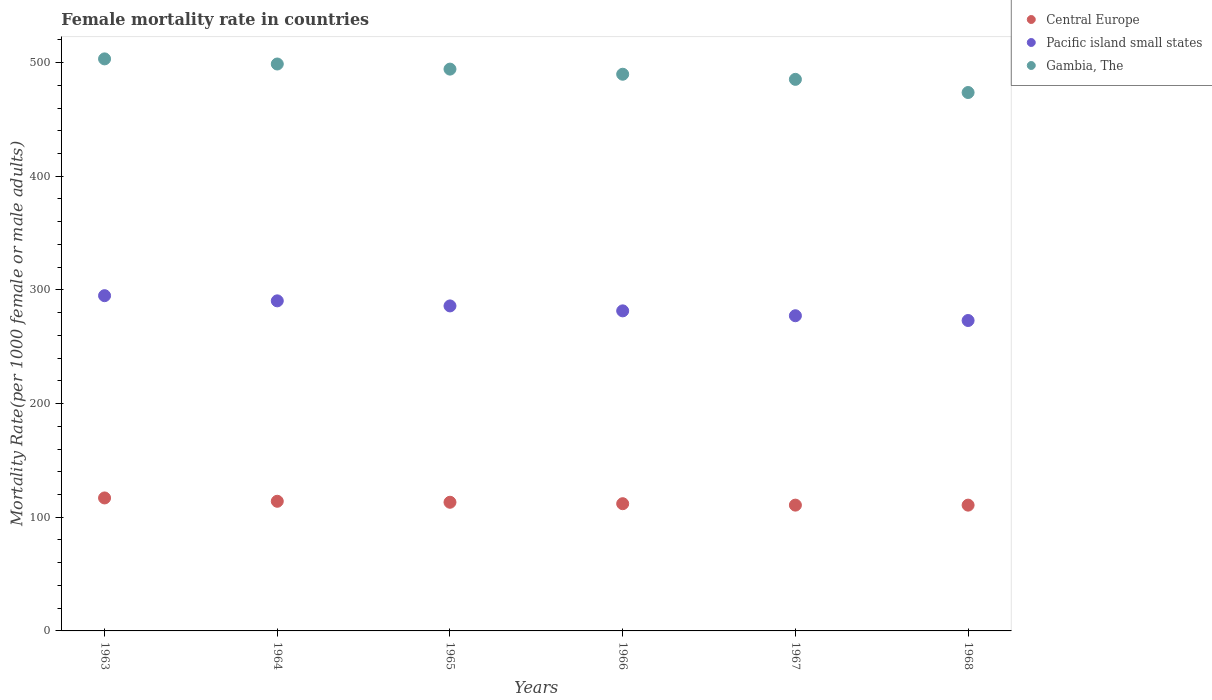How many different coloured dotlines are there?
Offer a terse response. 3. What is the female mortality rate in Gambia, The in 1965?
Provide a short and direct response. 494.21. Across all years, what is the maximum female mortality rate in Pacific island small states?
Ensure brevity in your answer.  294.91. Across all years, what is the minimum female mortality rate in Gambia, The?
Your response must be concise. 473.63. In which year was the female mortality rate in Pacific island small states maximum?
Give a very brief answer. 1963. In which year was the female mortality rate in Central Europe minimum?
Make the answer very short. 1968. What is the total female mortality rate in Pacific island small states in the graph?
Provide a short and direct response. 1703.05. What is the difference between the female mortality rate in Gambia, The in 1966 and that in 1968?
Give a very brief answer. 16.08. What is the difference between the female mortality rate in Central Europe in 1966 and the female mortality rate in Gambia, The in 1967?
Your answer should be compact. -373.3. What is the average female mortality rate in Pacific island small states per year?
Keep it short and to the point. 283.84. In the year 1967, what is the difference between the female mortality rate in Gambia, The and female mortality rate in Central Europe?
Your answer should be very brief. 374.55. In how many years, is the female mortality rate in Pacific island small states greater than 240?
Offer a very short reply. 6. What is the ratio of the female mortality rate in Pacific island small states in 1964 to that in 1965?
Offer a terse response. 1.02. Is the female mortality rate in Pacific island small states in 1966 less than that in 1967?
Make the answer very short. No. Is the difference between the female mortality rate in Gambia, The in 1963 and 1965 greater than the difference between the female mortality rate in Central Europe in 1963 and 1965?
Provide a succinct answer. Yes. What is the difference between the highest and the second highest female mortality rate in Central Europe?
Your response must be concise. 2.92. What is the difference between the highest and the lowest female mortality rate in Central Europe?
Make the answer very short. 6.32. In how many years, is the female mortality rate in Gambia, The greater than the average female mortality rate in Gambia, The taken over all years?
Provide a short and direct response. 3. Does the female mortality rate in Gambia, The monotonically increase over the years?
Make the answer very short. No. Is the female mortality rate in Central Europe strictly less than the female mortality rate in Pacific island small states over the years?
Your answer should be very brief. Yes. How many dotlines are there?
Your answer should be very brief. 3. Does the graph contain grids?
Provide a succinct answer. No. Where does the legend appear in the graph?
Make the answer very short. Top right. How many legend labels are there?
Offer a terse response. 3. What is the title of the graph?
Offer a terse response. Female mortality rate in countries. Does "Marshall Islands" appear as one of the legend labels in the graph?
Give a very brief answer. No. What is the label or title of the Y-axis?
Keep it short and to the point. Mortality Rate(per 1000 female or male adults). What is the Mortality Rate(per 1000 female or male adults) in Central Europe in 1963?
Your answer should be very brief. 116.97. What is the Mortality Rate(per 1000 female or male adults) in Pacific island small states in 1963?
Provide a succinct answer. 294.91. What is the Mortality Rate(per 1000 female or male adults) of Gambia, The in 1963?
Give a very brief answer. 503.21. What is the Mortality Rate(per 1000 female or male adults) in Central Europe in 1964?
Your response must be concise. 114.05. What is the Mortality Rate(per 1000 female or male adults) of Pacific island small states in 1964?
Offer a terse response. 290.36. What is the Mortality Rate(per 1000 female or male adults) in Gambia, The in 1964?
Give a very brief answer. 498.71. What is the Mortality Rate(per 1000 female or male adults) of Central Europe in 1965?
Provide a short and direct response. 113.18. What is the Mortality Rate(per 1000 female or male adults) in Pacific island small states in 1965?
Your answer should be very brief. 285.9. What is the Mortality Rate(per 1000 female or male adults) in Gambia, The in 1965?
Make the answer very short. 494.21. What is the Mortality Rate(per 1000 female or male adults) of Central Europe in 1966?
Provide a succinct answer. 111.91. What is the Mortality Rate(per 1000 female or male adults) in Pacific island small states in 1966?
Offer a terse response. 281.55. What is the Mortality Rate(per 1000 female or male adults) of Gambia, The in 1966?
Keep it short and to the point. 489.71. What is the Mortality Rate(per 1000 female or male adults) in Central Europe in 1967?
Your answer should be compact. 110.66. What is the Mortality Rate(per 1000 female or male adults) in Pacific island small states in 1967?
Offer a very short reply. 277.26. What is the Mortality Rate(per 1000 female or male adults) in Gambia, The in 1967?
Your response must be concise. 485.21. What is the Mortality Rate(per 1000 female or male adults) of Central Europe in 1968?
Your response must be concise. 110.65. What is the Mortality Rate(per 1000 female or male adults) in Pacific island small states in 1968?
Your answer should be compact. 273.07. What is the Mortality Rate(per 1000 female or male adults) in Gambia, The in 1968?
Offer a terse response. 473.63. Across all years, what is the maximum Mortality Rate(per 1000 female or male adults) of Central Europe?
Provide a succinct answer. 116.97. Across all years, what is the maximum Mortality Rate(per 1000 female or male adults) in Pacific island small states?
Make the answer very short. 294.91. Across all years, what is the maximum Mortality Rate(per 1000 female or male adults) of Gambia, The?
Your response must be concise. 503.21. Across all years, what is the minimum Mortality Rate(per 1000 female or male adults) of Central Europe?
Make the answer very short. 110.65. Across all years, what is the minimum Mortality Rate(per 1000 female or male adults) of Pacific island small states?
Provide a succinct answer. 273.07. Across all years, what is the minimum Mortality Rate(per 1000 female or male adults) in Gambia, The?
Your response must be concise. 473.63. What is the total Mortality Rate(per 1000 female or male adults) of Central Europe in the graph?
Your answer should be compact. 677.43. What is the total Mortality Rate(per 1000 female or male adults) of Pacific island small states in the graph?
Offer a very short reply. 1703.05. What is the total Mortality Rate(per 1000 female or male adults) of Gambia, The in the graph?
Your answer should be very brief. 2944.68. What is the difference between the Mortality Rate(per 1000 female or male adults) in Central Europe in 1963 and that in 1964?
Provide a succinct answer. 2.92. What is the difference between the Mortality Rate(per 1000 female or male adults) in Pacific island small states in 1963 and that in 1964?
Make the answer very short. 4.55. What is the difference between the Mortality Rate(per 1000 female or male adults) in Gambia, The in 1963 and that in 1964?
Your answer should be compact. 4.5. What is the difference between the Mortality Rate(per 1000 female or male adults) of Central Europe in 1963 and that in 1965?
Offer a terse response. 3.79. What is the difference between the Mortality Rate(per 1000 female or male adults) in Pacific island small states in 1963 and that in 1965?
Make the answer very short. 9.01. What is the difference between the Mortality Rate(per 1000 female or male adults) of Gambia, The in 1963 and that in 1965?
Provide a short and direct response. 9. What is the difference between the Mortality Rate(per 1000 female or male adults) in Central Europe in 1963 and that in 1966?
Your answer should be very brief. 5.06. What is the difference between the Mortality Rate(per 1000 female or male adults) of Pacific island small states in 1963 and that in 1966?
Make the answer very short. 13.37. What is the difference between the Mortality Rate(per 1000 female or male adults) in Gambia, The in 1963 and that in 1966?
Provide a succinct answer. 13.5. What is the difference between the Mortality Rate(per 1000 female or male adults) in Central Europe in 1963 and that in 1967?
Offer a very short reply. 6.31. What is the difference between the Mortality Rate(per 1000 female or male adults) of Pacific island small states in 1963 and that in 1967?
Ensure brevity in your answer.  17.65. What is the difference between the Mortality Rate(per 1000 female or male adults) of Gambia, The in 1963 and that in 1967?
Offer a terse response. 18. What is the difference between the Mortality Rate(per 1000 female or male adults) in Central Europe in 1963 and that in 1968?
Ensure brevity in your answer.  6.32. What is the difference between the Mortality Rate(per 1000 female or male adults) of Pacific island small states in 1963 and that in 1968?
Offer a very short reply. 21.85. What is the difference between the Mortality Rate(per 1000 female or male adults) in Gambia, The in 1963 and that in 1968?
Provide a short and direct response. 29.58. What is the difference between the Mortality Rate(per 1000 female or male adults) of Central Europe in 1964 and that in 1965?
Offer a very short reply. 0.87. What is the difference between the Mortality Rate(per 1000 female or male adults) of Pacific island small states in 1964 and that in 1965?
Provide a short and direct response. 4.46. What is the difference between the Mortality Rate(per 1000 female or male adults) in Gambia, The in 1964 and that in 1965?
Keep it short and to the point. 4.5. What is the difference between the Mortality Rate(per 1000 female or male adults) in Central Europe in 1964 and that in 1966?
Give a very brief answer. 2.14. What is the difference between the Mortality Rate(per 1000 female or male adults) in Pacific island small states in 1964 and that in 1966?
Keep it short and to the point. 8.81. What is the difference between the Mortality Rate(per 1000 female or male adults) in Gambia, The in 1964 and that in 1966?
Ensure brevity in your answer.  9. What is the difference between the Mortality Rate(per 1000 female or male adults) of Central Europe in 1964 and that in 1967?
Give a very brief answer. 3.39. What is the difference between the Mortality Rate(per 1000 female or male adults) of Pacific island small states in 1964 and that in 1967?
Provide a short and direct response. 13.1. What is the difference between the Mortality Rate(per 1000 female or male adults) in Gambia, The in 1964 and that in 1967?
Offer a terse response. 13.5. What is the difference between the Mortality Rate(per 1000 female or male adults) of Central Europe in 1964 and that in 1968?
Provide a short and direct response. 3.4. What is the difference between the Mortality Rate(per 1000 female or male adults) in Pacific island small states in 1964 and that in 1968?
Keep it short and to the point. 17.29. What is the difference between the Mortality Rate(per 1000 female or male adults) of Gambia, The in 1964 and that in 1968?
Give a very brief answer. 25.08. What is the difference between the Mortality Rate(per 1000 female or male adults) in Central Europe in 1965 and that in 1966?
Ensure brevity in your answer.  1.27. What is the difference between the Mortality Rate(per 1000 female or male adults) in Pacific island small states in 1965 and that in 1966?
Your answer should be very brief. 4.35. What is the difference between the Mortality Rate(per 1000 female or male adults) in Gambia, The in 1965 and that in 1966?
Your response must be concise. 4.5. What is the difference between the Mortality Rate(per 1000 female or male adults) of Central Europe in 1965 and that in 1967?
Provide a succinct answer. 2.52. What is the difference between the Mortality Rate(per 1000 female or male adults) of Pacific island small states in 1965 and that in 1967?
Offer a terse response. 8.64. What is the difference between the Mortality Rate(per 1000 female or male adults) in Gambia, The in 1965 and that in 1967?
Ensure brevity in your answer.  9. What is the difference between the Mortality Rate(per 1000 female or male adults) in Central Europe in 1965 and that in 1968?
Provide a succinct answer. 2.53. What is the difference between the Mortality Rate(per 1000 female or male adults) of Pacific island small states in 1965 and that in 1968?
Make the answer very short. 12.83. What is the difference between the Mortality Rate(per 1000 female or male adults) in Gambia, The in 1965 and that in 1968?
Your answer should be very brief. 20.58. What is the difference between the Mortality Rate(per 1000 female or male adults) in Central Europe in 1966 and that in 1967?
Offer a very short reply. 1.25. What is the difference between the Mortality Rate(per 1000 female or male adults) in Pacific island small states in 1966 and that in 1967?
Offer a very short reply. 4.29. What is the difference between the Mortality Rate(per 1000 female or male adults) in Gambia, The in 1966 and that in 1967?
Keep it short and to the point. 4.5. What is the difference between the Mortality Rate(per 1000 female or male adults) in Central Europe in 1966 and that in 1968?
Give a very brief answer. 1.26. What is the difference between the Mortality Rate(per 1000 female or male adults) in Pacific island small states in 1966 and that in 1968?
Ensure brevity in your answer.  8.48. What is the difference between the Mortality Rate(per 1000 female or male adults) of Gambia, The in 1966 and that in 1968?
Provide a succinct answer. 16.08. What is the difference between the Mortality Rate(per 1000 female or male adults) in Central Europe in 1967 and that in 1968?
Your answer should be compact. 0.01. What is the difference between the Mortality Rate(per 1000 female or male adults) of Pacific island small states in 1967 and that in 1968?
Offer a very short reply. 4.2. What is the difference between the Mortality Rate(per 1000 female or male adults) in Gambia, The in 1967 and that in 1968?
Offer a terse response. 11.58. What is the difference between the Mortality Rate(per 1000 female or male adults) of Central Europe in 1963 and the Mortality Rate(per 1000 female or male adults) of Pacific island small states in 1964?
Your answer should be very brief. -173.39. What is the difference between the Mortality Rate(per 1000 female or male adults) of Central Europe in 1963 and the Mortality Rate(per 1000 female or male adults) of Gambia, The in 1964?
Provide a short and direct response. -381.74. What is the difference between the Mortality Rate(per 1000 female or male adults) in Pacific island small states in 1963 and the Mortality Rate(per 1000 female or male adults) in Gambia, The in 1964?
Offer a very short reply. -203.8. What is the difference between the Mortality Rate(per 1000 female or male adults) of Central Europe in 1963 and the Mortality Rate(per 1000 female or male adults) of Pacific island small states in 1965?
Offer a very short reply. -168.93. What is the difference between the Mortality Rate(per 1000 female or male adults) in Central Europe in 1963 and the Mortality Rate(per 1000 female or male adults) in Gambia, The in 1965?
Offer a very short reply. -377.24. What is the difference between the Mortality Rate(per 1000 female or male adults) of Pacific island small states in 1963 and the Mortality Rate(per 1000 female or male adults) of Gambia, The in 1965?
Give a very brief answer. -199.3. What is the difference between the Mortality Rate(per 1000 female or male adults) in Central Europe in 1963 and the Mortality Rate(per 1000 female or male adults) in Pacific island small states in 1966?
Your response must be concise. -164.57. What is the difference between the Mortality Rate(per 1000 female or male adults) of Central Europe in 1963 and the Mortality Rate(per 1000 female or male adults) of Gambia, The in 1966?
Make the answer very short. -372.73. What is the difference between the Mortality Rate(per 1000 female or male adults) in Pacific island small states in 1963 and the Mortality Rate(per 1000 female or male adults) in Gambia, The in 1966?
Provide a short and direct response. -194.79. What is the difference between the Mortality Rate(per 1000 female or male adults) of Central Europe in 1963 and the Mortality Rate(per 1000 female or male adults) of Pacific island small states in 1967?
Offer a very short reply. -160.29. What is the difference between the Mortality Rate(per 1000 female or male adults) in Central Europe in 1963 and the Mortality Rate(per 1000 female or male adults) in Gambia, The in 1967?
Keep it short and to the point. -368.23. What is the difference between the Mortality Rate(per 1000 female or male adults) of Pacific island small states in 1963 and the Mortality Rate(per 1000 female or male adults) of Gambia, The in 1967?
Ensure brevity in your answer.  -190.29. What is the difference between the Mortality Rate(per 1000 female or male adults) of Central Europe in 1963 and the Mortality Rate(per 1000 female or male adults) of Pacific island small states in 1968?
Give a very brief answer. -156.09. What is the difference between the Mortality Rate(per 1000 female or male adults) of Central Europe in 1963 and the Mortality Rate(per 1000 female or male adults) of Gambia, The in 1968?
Your response must be concise. -356.66. What is the difference between the Mortality Rate(per 1000 female or male adults) in Pacific island small states in 1963 and the Mortality Rate(per 1000 female or male adults) in Gambia, The in 1968?
Your answer should be very brief. -178.72. What is the difference between the Mortality Rate(per 1000 female or male adults) in Central Europe in 1964 and the Mortality Rate(per 1000 female or male adults) in Pacific island small states in 1965?
Keep it short and to the point. -171.85. What is the difference between the Mortality Rate(per 1000 female or male adults) of Central Europe in 1964 and the Mortality Rate(per 1000 female or male adults) of Gambia, The in 1965?
Keep it short and to the point. -380.16. What is the difference between the Mortality Rate(per 1000 female or male adults) in Pacific island small states in 1964 and the Mortality Rate(per 1000 female or male adults) in Gambia, The in 1965?
Offer a very short reply. -203.85. What is the difference between the Mortality Rate(per 1000 female or male adults) of Central Europe in 1964 and the Mortality Rate(per 1000 female or male adults) of Pacific island small states in 1966?
Provide a succinct answer. -167.5. What is the difference between the Mortality Rate(per 1000 female or male adults) of Central Europe in 1964 and the Mortality Rate(per 1000 female or male adults) of Gambia, The in 1966?
Provide a short and direct response. -375.66. What is the difference between the Mortality Rate(per 1000 female or male adults) of Pacific island small states in 1964 and the Mortality Rate(per 1000 female or male adults) of Gambia, The in 1966?
Your answer should be very brief. -199.35. What is the difference between the Mortality Rate(per 1000 female or male adults) in Central Europe in 1964 and the Mortality Rate(per 1000 female or male adults) in Pacific island small states in 1967?
Provide a succinct answer. -163.21. What is the difference between the Mortality Rate(per 1000 female or male adults) in Central Europe in 1964 and the Mortality Rate(per 1000 female or male adults) in Gambia, The in 1967?
Offer a very short reply. -371.16. What is the difference between the Mortality Rate(per 1000 female or male adults) of Pacific island small states in 1964 and the Mortality Rate(per 1000 female or male adults) of Gambia, The in 1967?
Offer a very short reply. -194.85. What is the difference between the Mortality Rate(per 1000 female or male adults) in Central Europe in 1964 and the Mortality Rate(per 1000 female or male adults) in Pacific island small states in 1968?
Your response must be concise. -159.01. What is the difference between the Mortality Rate(per 1000 female or male adults) in Central Europe in 1964 and the Mortality Rate(per 1000 female or male adults) in Gambia, The in 1968?
Provide a short and direct response. -359.58. What is the difference between the Mortality Rate(per 1000 female or male adults) of Pacific island small states in 1964 and the Mortality Rate(per 1000 female or male adults) of Gambia, The in 1968?
Keep it short and to the point. -183.27. What is the difference between the Mortality Rate(per 1000 female or male adults) of Central Europe in 1965 and the Mortality Rate(per 1000 female or male adults) of Pacific island small states in 1966?
Make the answer very short. -168.37. What is the difference between the Mortality Rate(per 1000 female or male adults) in Central Europe in 1965 and the Mortality Rate(per 1000 female or male adults) in Gambia, The in 1966?
Your answer should be compact. -376.53. What is the difference between the Mortality Rate(per 1000 female or male adults) of Pacific island small states in 1965 and the Mortality Rate(per 1000 female or male adults) of Gambia, The in 1966?
Keep it short and to the point. -203.81. What is the difference between the Mortality Rate(per 1000 female or male adults) in Central Europe in 1965 and the Mortality Rate(per 1000 female or male adults) in Pacific island small states in 1967?
Ensure brevity in your answer.  -164.08. What is the difference between the Mortality Rate(per 1000 female or male adults) in Central Europe in 1965 and the Mortality Rate(per 1000 female or male adults) in Gambia, The in 1967?
Your answer should be compact. -372.03. What is the difference between the Mortality Rate(per 1000 female or male adults) in Pacific island small states in 1965 and the Mortality Rate(per 1000 female or male adults) in Gambia, The in 1967?
Offer a very short reply. -199.31. What is the difference between the Mortality Rate(per 1000 female or male adults) in Central Europe in 1965 and the Mortality Rate(per 1000 female or male adults) in Pacific island small states in 1968?
Offer a very short reply. -159.88. What is the difference between the Mortality Rate(per 1000 female or male adults) of Central Europe in 1965 and the Mortality Rate(per 1000 female or male adults) of Gambia, The in 1968?
Offer a very short reply. -360.45. What is the difference between the Mortality Rate(per 1000 female or male adults) in Pacific island small states in 1965 and the Mortality Rate(per 1000 female or male adults) in Gambia, The in 1968?
Your answer should be compact. -187.73. What is the difference between the Mortality Rate(per 1000 female or male adults) of Central Europe in 1966 and the Mortality Rate(per 1000 female or male adults) of Pacific island small states in 1967?
Make the answer very short. -165.35. What is the difference between the Mortality Rate(per 1000 female or male adults) in Central Europe in 1966 and the Mortality Rate(per 1000 female or male adults) in Gambia, The in 1967?
Ensure brevity in your answer.  -373.3. What is the difference between the Mortality Rate(per 1000 female or male adults) in Pacific island small states in 1966 and the Mortality Rate(per 1000 female or male adults) in Gambia, The in 1967?
Your answer should be very brief. -203.66. What is the difference between the Mortality Rate(per 1000 female or male adults) in Central Europe in 1966 and the Mortality Rate(per 1000 female or male adults) in Pacific island small states in 1968?
Ensure brevity in your answer.  -161.15. What is the difference between the Mortality Rate(per 1000 female or male adults) in Central Europe in 1966 and the Mortality Rate(per 1000 female or male adults) in Gambia, The in 1968?
Ensure brevity in your answer.  -361.72. What is the difference between the Mortality Rate(per 1000 female or male adults) in Pacific island small states in 1966 and the Mortality Rate(per 1000 female or male adults) in Gambia, The in 1968?
Keep it short and to the point. -192.08. What is the difference between the Mortality Rate(per 1000 female or male adults) in Central Europe in 1967 and the Mortality Rate(per 1000 female or male adults) in Pacific island small states in 1968?
Your answer should be very brief. -162.4. What is the difference between the Mortality Rate(per 1000 female or male adults) in Central Europe in 1967 and the Mortality Rate(per 1000 female or male adults) in Gambia, The in 1968?
Offer a terse response. -362.97. What is the difference between the Mortality Rate(per 1000 female or male adults) of Pacific island small states in 1967 and the Mortality Rate(per 1000 female or male adults) of Gambia, The in 1968?
Your response must be concise. -196.37. What is the average Mortality Rate(per 1000 female or male adults) in Central Europe per year?
Ensure brevity in your answer.  112.91. What is the average Mortality Rate(per 1000 female or male adults) in Pacific island small states per year?
Keep it short and to the point. 283.84. What is the average Mortality Rate(per 1000 female or male adults) in Gambia, The per year?
Offer a terse response. 490.78. In the year 1963, what is the difference between the Mortality Rate(per 1000 female or male adults) of Central Europe and Mortality Rate(per 1000 female or male adults) of Pacific island small states?
Provide a short and direct response. -177.94. In the year 1963, what is the difference between the Mortality Rate(per 1000 female or male adults) of Central Europe and Mortality Rate(per 1000 female or male adults) of Gambia, The?
Give a very brief answer. -386.24. In the year 1963, what is the difference between the Mortality Rate(per 1000 female or male adults) in Pacific island small states and Mortality Rate(per 1000 female or male adults) in Gambia, The?
Your answer should be very brief. -208.3. In the year 1964, what is the difference between the Mortality Rate(per 1000 female or male adults) of Central Europe and Mortality Rate(per 1000 female or male adults) of Pacific island small states?
Provide a short and direct response. -176.31. In the year 1964, what is the difference between the Mortality Rate(per 1000 female or male adults) in Central Europe and Mortality Rate(per 1000 female or male adults) in Gambia, The?
Ensure brevity in your answer.  -384.66. In the year 1964, what is the difference between the Mortality Rate(per 1000 female or male adults) of Pacific island small states and Mortality Rate(per 1000 female or male adults) of Gambia, The?
Make the answer very short. -208.35. In the year 1965, what is the difference between the Mortality Rate(per 1000 female or male adults) of Central Europe and Mortality Rate(per 1000 female or male adults) of Pacific island small states?
Provide a short and direct response. -172.72. In the year 1965, what is the difference between the Mortality Rate(per 1000 female or male adults) in Central Europe and Mortality Rate(per 1000 female or male adults) in Gambia, The?
Keep it short and to the point. -381.03. In the year 1965, what is the difference between the Mortality Rate(per 1000 female or male adults) in Pacific island small states and Mortality Rate(per 1000 female or male adults) in Gambia, The?
Ensure brevity in your answer.  -208.31. In the year 1966, what is the difference between the Mortality Rate(per 1000 female or male adults) in Central Europe and Mortality Rate(per 1000 female or male adults) in Pacific island small states?
Give a very brief answer. -169.64. In the year 1966, what is the difference between the Mortality Rate(per 1000 female or male adults) of Central Europe and Mortality Rate(per 1000 female or male adults) of Gambia, The?
Provide a short and direct response. -377.8. In the year 1966, what is the difference between the Mortality Rate(per 1000 female or male adults) in Pacific island small states and Mortality Rate(per 1000 female or male adults) in Gambia, The?
Offer a very short reply. -208.16. In the year 1967, what is the difference between the Mortality Rate(per 1000 female or male adults) in Central Europe and Mortality Rate(per 1000 female or male adults) in Pacific island small states?
Your answer should be very brief. -166.6. In the year 1967, what is the difference between the Mortality Rate(per 1000 female or male adults) in Central Europe and Mortality Rate(per 1000 female or male adults) in Gambia, The?
Offer a terse response. -374.55. In the year 1967, what is the difference between the Mortality Rate(per 1000 female or male adults) in Pacific island small states and Mortality Rate(per 1000 female or male adults) in Gambia, The?
Your answer should be very brief. -207.95. In the year 1968, what is the difference between the Mortality Rate(per 1000 female or male adults) of Central Europe and Mortality Rate(per 1000 female or male adults) of Pacific island small states?
Your answer should be compact. -162.41. In the year 1968, what is the difference between the Mortality Rate(per 1000 female or male adults) of Central Europe and Mortality Rate(per 1000 female or male adults) of Gambia, The?
Provide a succinct answer. -362.98. In the year 1968, what is the difference between the Mortality Rate(per 1000 female or male adults) in Pacific island small states and Mortality Rate(per 1000 female or male adults) in Gambia, The?
Offer a terse response. -200.56. What is the ratio of the Mortality Rate(per 1000 female or male adults) of Central Europe in 1963 to that in 1964?
Ensure brevity in your answer.  1.03. What is the ratio of the Mortality Rate(per 1000 female or male adults) of Pacific island small states in 1963 to that in 1964?
Keep it short and to the point. 1.02. What is the ratio of the Mortality Rate(per 1000 female or male adults) of Gambia, The in 1963 to that in 1964?
Provide a short and direct response. 1.01. What is the ratio of the Mortality Rate(per 1000 female or male adults) in Central Europe in 1963 to that in 1965?
Keep it short and to the point. 1.03. What is the ratio of the Mortality Rate(per 1000 female or male adults) in Pacific island small states in 1963 to that in 1965?
Your answer should be compact. 1.03. What is the ratio of the Mortality Rate(per 1000 female or male adults) of Gambia, The in 1963 to that in 1965?
Your answer should be compact. 1.02. What is the ratio of the Mortality Rate(per 1000 female or male adults) in Central Europe in 1963 to that in 1966?
Ensure brevity in your answer.  1.05. What is the ratio of the Mortality Rate(per 1000 female or male adults) of Pacific island small states in 1963 to that in 1966?
Your response must be concise. 1.05. What is the ratio of the Mortality Rate(per 1000 female or male adults) in Gambia, The in 1963 to that in 1966?
Offer a terse response. 1.03. What is the ratio of the Mortality Rate(per 1000 female or male adults) of Central Europe in 1963 to that in 1967?
Offer a terse response. 1.06. What is the ratio of the Mortality Rate(per 1000 female or male adults) in Pacific island small states in 1963 to that in 1967?
Make the answer very short. 1.06. What is the ratio of the Mortality Rate(per 1000 female or male adults) of Gambia, The in 1963 to that in 1967?
Give a very brief answer. 1.04. What is the ratio of the Mortality Rate(per 1000 female or male adults) in Central Europe in 1963 to that in 1968?
Your answer should be very brief. 1.06. What is the ratio of the Mortality Rate(per 1000 female or male adults) of Pacific island small states in 1963 to that in 1968?
Keep it short and to the point. 1.08. What is the ratio of the Mortality Rate(per 1000 female or male adults) in Gambia, The in 1963 to that in 1968?
Provide a short and direct response. 1.06. What is the ratio of the Mortality Rate(per 1000 female or male adults) of Central Europe in 1964 to that in 1965?
Provide a succinct answer. 1.01. What is the ratio of the Mortality Rate(per 1000 female or male adults) of Pacific island small states in 1964 to that in 1965?
Offer a very short reply. 1.02. What is the ratio of the Mortality Rate(per 1000 female or male adults) of Gambia, The in 1964 to that in 1965?
Your answer should be very brief. 1.01. What is the ratio of the Mortality Rate(per 1000 female or male adults) in Central Europe in 1964 to that in 1966?
Offer a very short reply. 1.02. What is the ratio of the Mortality Rate(per 1000 female or male adults) in Pacific island small states in 1964 to that in 1966?
Provide a short and direct response. 1.03. What is the ratio of the Mortality Rate(per 1000 female or male adults) in Gambia, The in 1964 to that in 1966?
Offer a very short reply. 1.02. What is the ratio of the Mortality Rate(per 1000 female or male adults) of Central Europe in 1964 to that in 1967?
Provide a succinct answer. 1.03. What is the ratio of the Mortality Rate(per 1000 female or male adults) of Pacific island small states in 1964 to that in 1967?
Provide a succinct answer. 1.05. What is the ratio of the Mortality Rate(per 1000 female or male adults) in Gambia, The in 1964 to that in 1967?
Offer a very short reply. 1.03. What is the ratio of the Mortality Rate(per 1000 female or male adults) of Central Europe in 1964 to that in 1968?
Offer a terse response. 1.03. What is the ratio of the Mortality Rate(per 1000 female or male adults) of Pacific island small states in 1964 to that in 1968?
Your response must be concise. 1.06. What is the ratio of the Mortality Rate(per 1000 female or male adults) of Gambia, The in 1964 to that in 1968?
Make the answer very short. 1.05. What is the ratio of the Mortality Rate(per 1000 female or male adults) of Central Europe in 1965 to that in 1966?
Ensure brevity in your answer.  1.01. What is the ratio of the Mortality Rate(per 1000 female or male adults) of Pacific island small states in 1965 to that in 1966?
Make the answer very short. 1.02. What is the ratio of the Mortality Rate(per 1000 female or male adults) in Gambia, The in 1965 to that in 1966?
Make the answer very short. 1.01. What is the ratio of the Mortality Rate(per 1000 female or male adults) of Central Europe in 1965 to that in 1967?
Your answer should be compact. 1.02. What is the ratio of the Mortality Rate(per 1000 female or male adults) of Pacific island small states in 1965 to that in 1967?
Your answer should be compact. 1.03. What is the ratio of the Mortality Rate(per 1000 female or male adults) of Gambia, The in 1965 to that in 1967?
Give a very brief answer. 1.02. What is the ratio of the Mortality Rate(per 1000 female or male adults) of Central Europe in 1965 to that in 1968?
Your answer should be very brief. 1.02. What is the ratio of the Mortality Rate(per 1000 female or male adults) in Pacific island small states in 1965 to that in 1968?
Your response must be concise. 1.05. What is the ratio of the Mortality Rate(per 1000 female or male adults) in Gambia, The in 1965 to that in 1968?
Offer a terse response. 1.04. What is the ratio of the Mortality Rate(per 1000 female or male adults) in Central Europe in 1966 to that in 1967?
Your answer should be very brief. 1.01. What is the ratio of the Mortality Rate(per 1000 female or male adults) in Pacific island small states in 1966 to that in 1967?
Provide a succinct answer. 1.02. What is the ratio of the Mortality Rate(per 1000 female or male adults) of Gambia, The in 1966 to that in 1967?
Your answer should be very brief. 1.01. What is the ratio of the Mortality Rate(per 1000 female or male adults) of Central Europe in 1966 to that in 1968?
Provide a succinct answer. 1.01. What is the ratio of the Mortality Rate(per 1000 female or male adults) in Pacific island small states in 1966 to that in 1968?
Provide a succinct answer. 1.03. What is the ratio of the Mortality Rate(per 1000 female or male adults) in Gambia, The in 1966 to that in 1968?
Provide a succinct answer. 1.03. What is the ratio of the Mortality Rate(per 1000 female or male adults) of Pacific island small states in 1967 to that in 1968?
Your answer should be very brief. 1.02. What is the ratio of the Mortality Rate(per 1000 female or male adults) of Gambia, The in 1967 to that in 1968?
Keep it short and to the point. 1.02. What is the difference between the highest and the second highest Mortality Rate(per 1000 female or male adults) of Central Europe?
Keep it short and to the point. 2.92. What is the difference between the highest and the second highest Mortality Rate(per 1000 female or male adults) of Pacific island small states?
Make the answer very short. 4.55. What is the difference between the highest and the second highest Mortality Rate(per 1000 female or male adults) of Gambia, The?
Your response must be concise. 4.5. What is the difference between the highest and the lowest Mortality Rate(per 1000 female or male adults) of Central Europe?
Provide a short and direct response. 6.32. What is the difference between the highest and the lowest Mortality Rate(per 1000 female or male adults) of Pacific island small states?
Provide a short and direct response. 21.85. What is the difference between the highest and the lowest Mortality Rate(per 1000 female or male adults) of Gambia, The?
Your response must be concise. 29.58. 